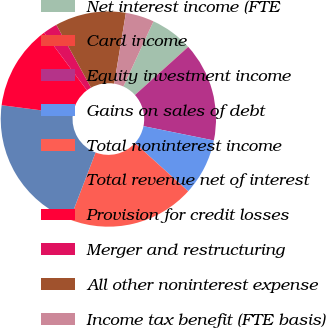<chart> <loc_0><loc_0><loc_500><loc_500><pie_chart><fcel>Net interest income (FTE<fcel>Card income<fcel>Equity investment income<fcel>Gains on sales of debt<fcel>Total noninterest income<fcel>Total revenue net of interest<fcel>Provision for credit losses<fcel>Merger and restructuring<fcel>All other noninterest expense<fcel>Income tax benefit (FTE basis)<nl><fcel>6.4%<fcel>0.03%<fcel>14.88%<fcel>8.52%<fcel>19.12%<fcel>21.24%<fcel>12.76%<fcel>2.16%<fcel>10.64%<fcel>4.28%<nl></chart> 